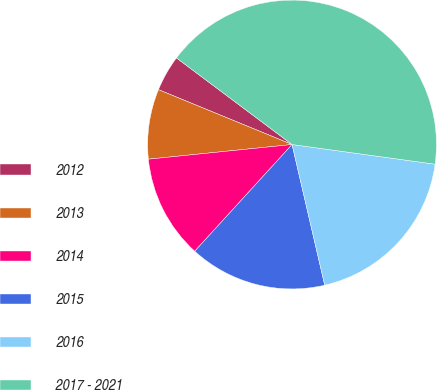<chart> <loc_0><loc_0><loc_500><loc_500><pie_chart><fcel>2012<fcel>2013<fcel>2014<fcel>2015<fcel>2016<fcel>2017 - 2021<nl><fcel>4.03%<fcel>7.82%<fcel>11.61%<fcel>15.4%<fcel>19.19%<fcel>41.94%<nl></chart> 